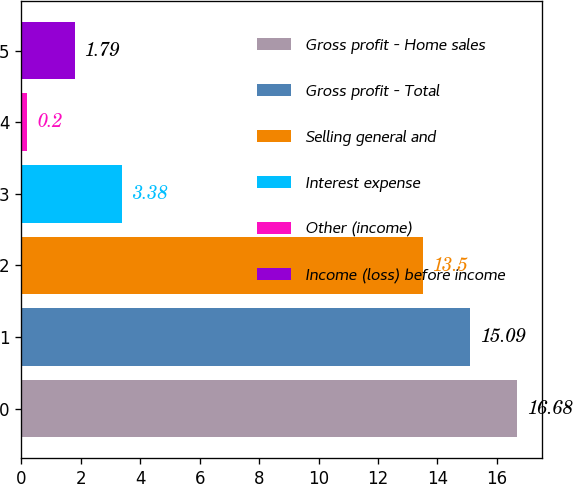Convert chart. <chart><loc_0><loc_0><loc_500><loc_500><bar_chart><fcel>Gross profit - Home sales<fcel>Gross profit - Total<fcel>Selling general and<fcel>Interest expense<fcel>Other (income)<fcel>Income (loss) before income<nl><fcel>16.68<fcel>15.09<fcel>13.5<fcel>3.38<fcel>0.2<fcel>1.79<nl></chart> 